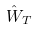Convert formula to latex. <formula><loc_0><loc_0><loc_500><loc_500>\hat { W } _ { T }</formula> 